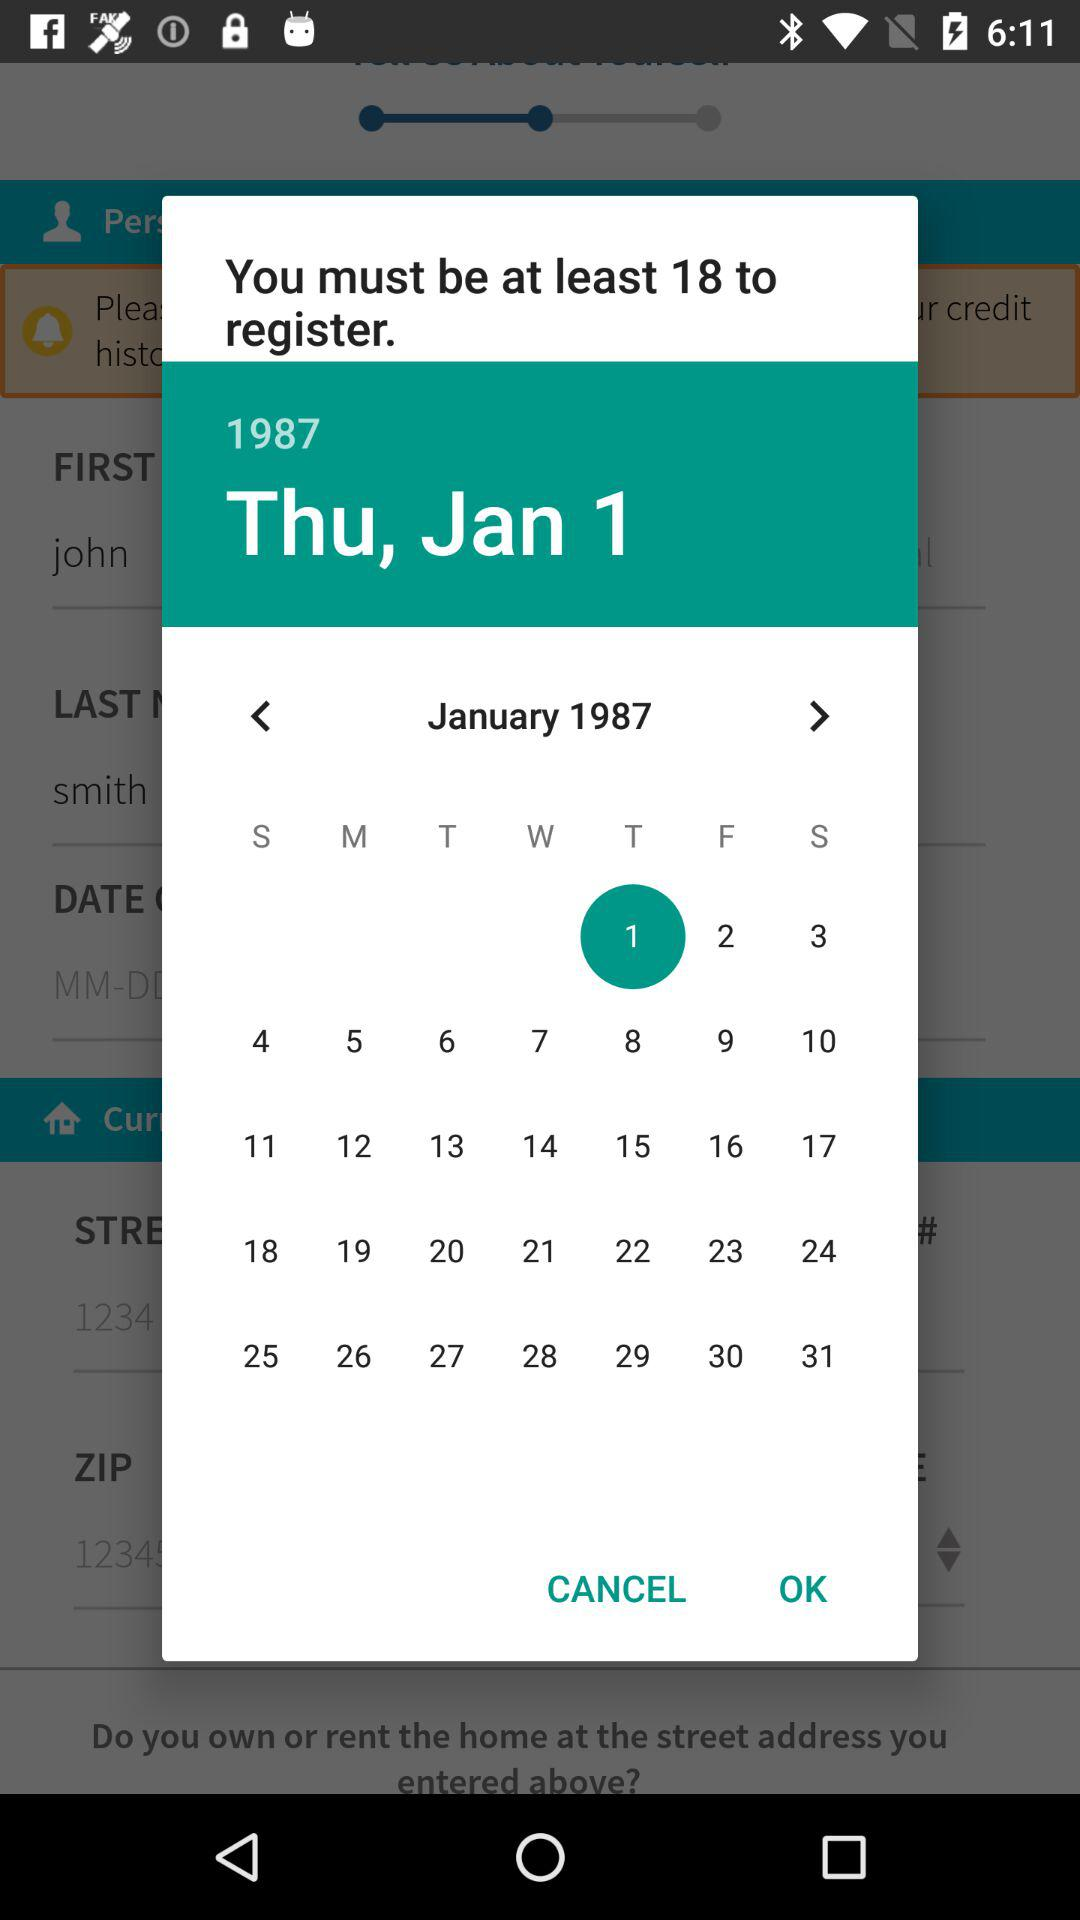Which city is mentioned in the address?
When the provided information is insufficient, respond with <no answer>. <no answer> 